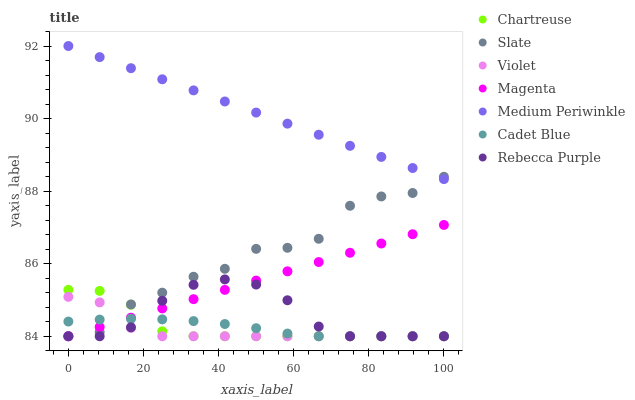Does Violet have the minimum area under the curve?
Answer yes or no. Yes. Does Medium Periwinkle have the maximum area under the curve?
Answer yes or no. Yes. Does Slate have the minimum area under the curve?
Answer yes or no. No. Does Slate have the maximum area under the curve?
Answer yes or no. No. Is Medium Periwinkle the smoothest?
Answer yes or no. Yes. Is Slate the roughest?
Answer yes or no. Yes. Is Slate the smoothest?
Answer yes or no. No. Is Medium Periwinkle the roughest?
Answer yes or no. No. Does Cadet Blue have the lowest value?
Answer yes or no. Yes. Does Medium Periwinkle have the lowest value?
Answer yes or no. No. Does Medium Periwinkle have the highest value?
Answer yes or no. Yes. Does Slate have the highest value?
Answer yes or no. No. Is Magenta less than Medium Periwinkle?
Answer yes or no. Yes. Is Medium Periwinkle greater than Cadet Blue?
Answer yes or no. Yes. Does Magenta intersect Violet?
Answer yes or no. Yes. Is Magenta less than Violet?
Answer yes or no. No. Is Magenta greater than Violet?
Answer yes or no. No. Does Magenta intersect Medium Periwinkle?
Answer yes or no. No. 